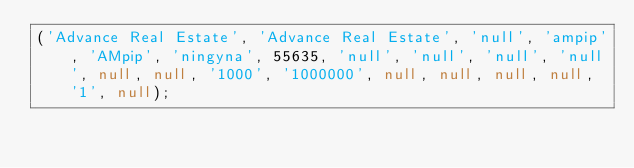Convert code to text. <code><loc_0><loc_0><loc_500><loc_500><_SQL_>('Advance Real Estate', 'Advance Real Estate', 'null', 'ampip', 'AMpip', 'ningyna', 55635, 'null', 'null', 'null', 'null', null, null, '1000', '1000000', null, null, null, null, '1', null);</code> 